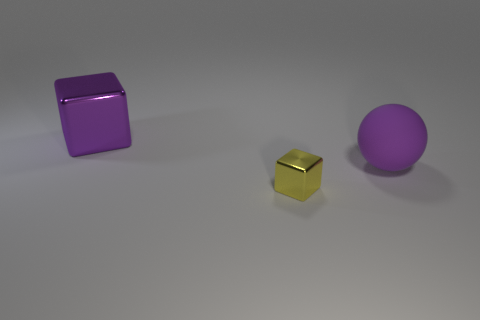How many big rubber balls are on the left side of the large object to the left of the purple matte sphere? There are no big rubber balls on the left side of the large object to the left of the purple matte sphere. The image shows three objects: a purple cube, a small gold cube, and a larger purple sphere. There are no rubber balls visible. 